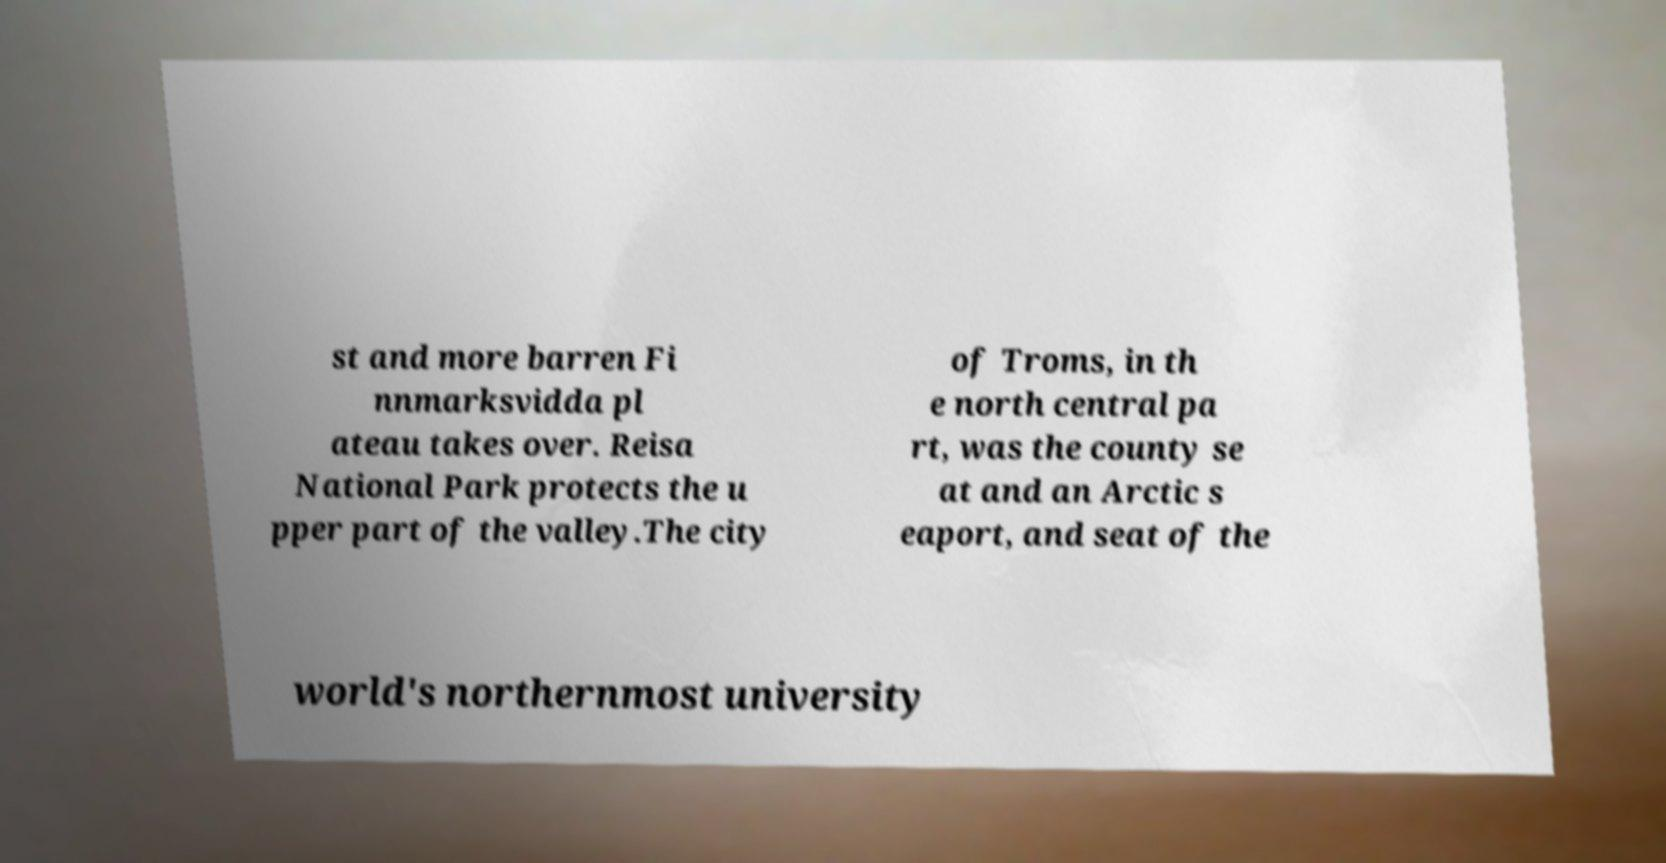For documentation purposes, I need the text within this image transcribed. Could you provide that? st and more barren Fi nnmarksvidda pl ateau takes over. Reisa National Park protects the u pper part of the valley.The city of Troms, in th e north central pa rt, was the county se at and an Arctic s eaport, and seat of the world's northernmost university 